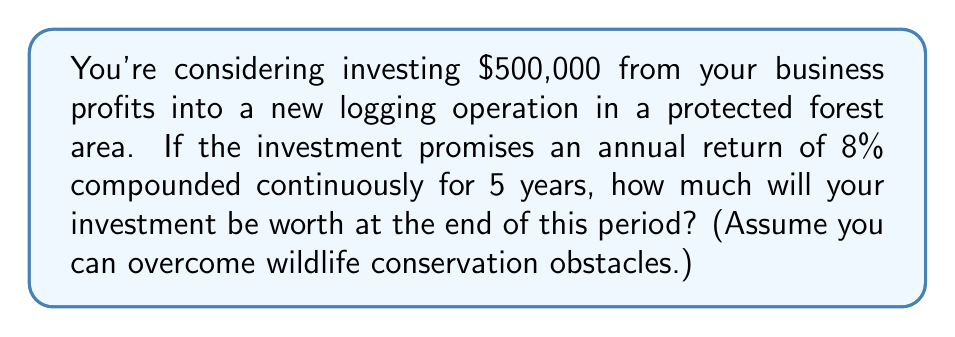Solve this math problem. To solve this problem, we'll use the formula for continuous compound interest:

$$A = P \cdot e^{rt}$$

Where:
$A$ = Final amount
$P$ = Principal (initial investment)
$r$ = Annual interest rate (as a decimal)
$t$ = Time in years
$e$ = Euler's number (approximately 2.71828)

Given:
$P = \$500,000$
$r = 0.08$ (8% expressed as a decimal)
$t = 5$ years

Let's substitute these values into the formula:

$$A = 500,000 \cdot e^{0.08 \cdot 5}$$

Now, let's calculate:

1) First, compute the exponent: $0.08 \cdot 5 = 0.4$

2) Calculate $e^{0.4}$:
   $$e^{0.4} \approx 1.4918$$

3) Multiply this by the principal:
   $$500,000 \cdot 1.4918 = 745,900$$

Therefore, after 5 years, the investment will be worth approximately $745,900.
Answer: $745,900 